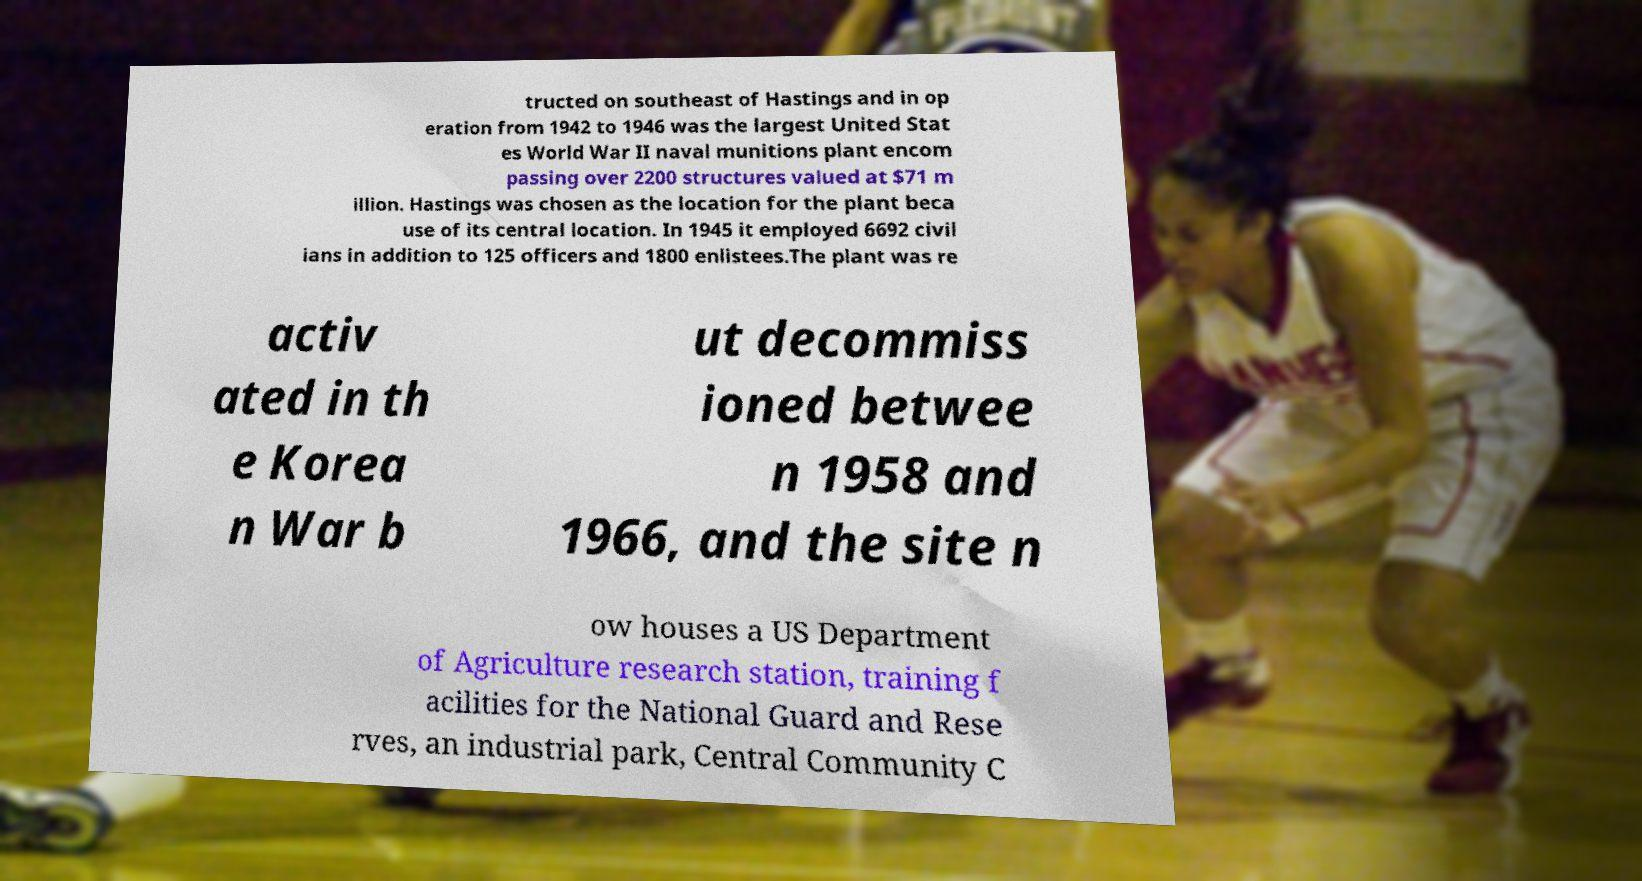Can you accurately transcribe the text from the provided image for me? tructed on southeast of Hastings and in op eration from 1942 to 1946 was the largest United Stat es World War II naval munitions plant encom passing over 2200 structures valued at $71 m illion. Hastings was chosen as the location for the plant beca use of its central location. In 1945 it employed 6692 civil ians in addition to 125 officers and 1800 enlistees.The plant was re activ ated in th e Korea n War b ut decommiss ioned betwee n 1958 and 1966, and the site n ow houses a US Department of Agriculture research station, training f acilities for the National Guard and Rese rves, an industrial park, Central Community C 